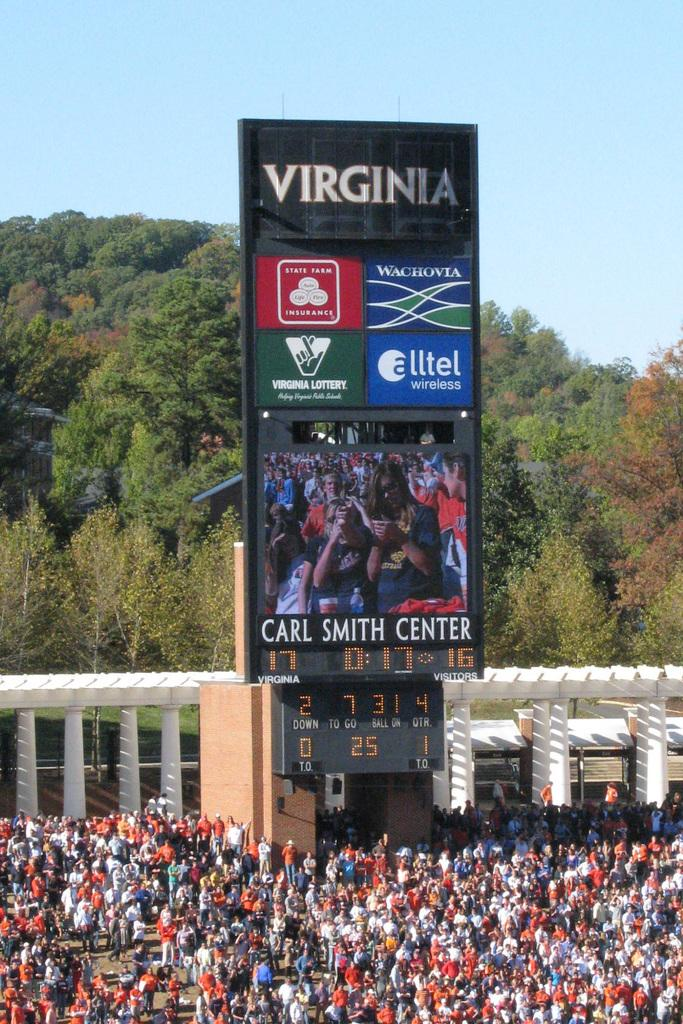<image>
Render a clear and concise summary of the photo. A large scoreboard from the Carl Smith Center in  Virginia. 